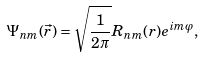<formula> <loc_0><loc_0><loc_500><loc_500>\Psi _ { n m } ( \vec { r } ) = \sqrt { \frac { 1 } { 2 \pi } } R _ { n m } ( r ) e ^ { i m \varphi } ,</formula> 